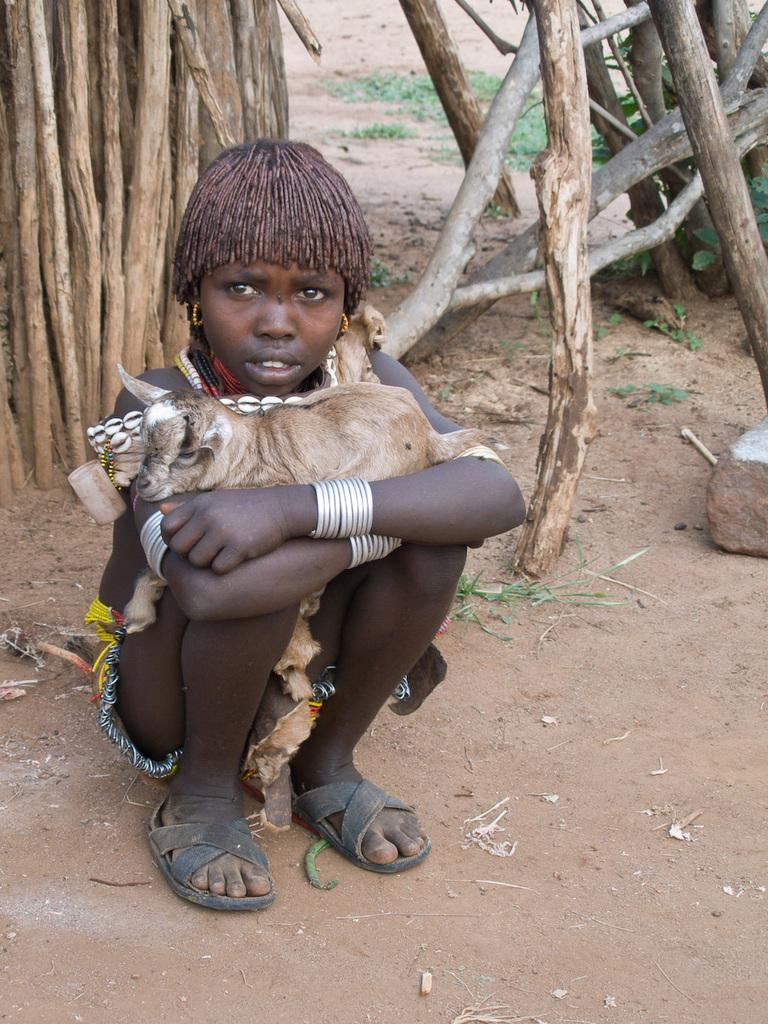What objects are at the top of the image? There are sticks at the top of the image. What is the main subject in the middle of the image? There is a child sitting in the middle of the image. What is the child holding in their hands? The child is holding an animal in their hands. What position does the pump hold in the image? There is no pump present in the image. How many times does the ball burst in the image? There is no ball present in the image, so it cannot burst. 